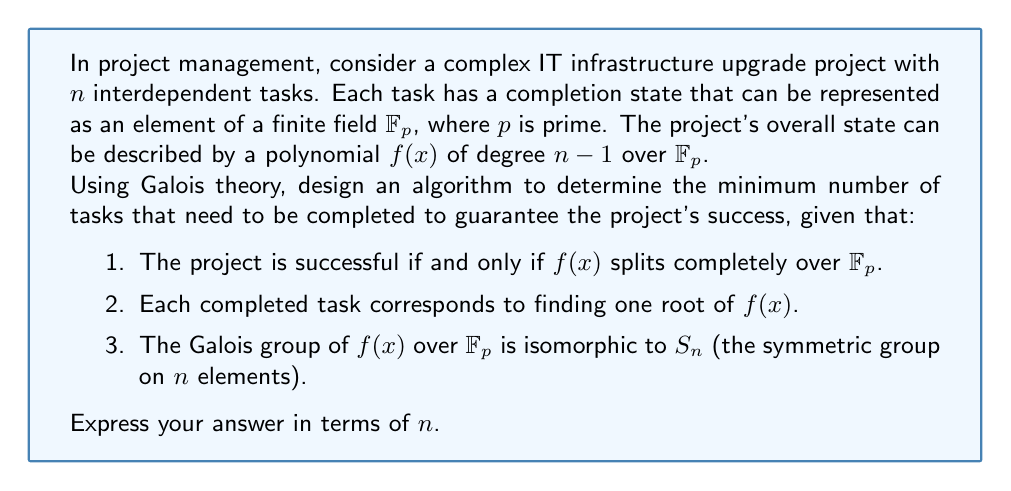Show me your answer to this math problem. Let's approach this step-by-step using Galois theory:

1) First, recall that for a polynomial $f(x)$ of degree $n$ over a field $F$, the Galois group $Gal(f/F)$ is a subgroup of $S_n$.

2) In this case, we're given that $Gal(f/\mathbb{F}_p) \cong S_n$, which means the polynomial is as complicated as possible over $\mathbb{F}_p$.

3) The Fundamental Theorem of Galois Theory states that there's a one-to-one correspondence between subfields of the splitting field of $f(x)$ and subgroups of $Gal(f/\mathbb{F}_p)$.

4) Each time we complete a task (find a root), we're essentially adjoining that root to $\mathbb{F}_p$. This corresponds to moving to a subfield of the splitting field.

5) The question is asking for the minimum number of roots we need to find to guarantee that all roots are in the field (i.e., the polynomial splits completely).

6) In Galois theory terms, we're looking for the smallest subgroup of $S_n$ that guarantees the corresponding fixed field is the entire splitting field.

7) The key insight is that $S_n$ is generated by transpositions. In fact, it's generated by the $n-1$ transpositions $(1 2), (2 3), ..., (n-1 n)$.

8) This means that if we fix $n-1$ roots, the last root must also be in our field, as the Galois group of the remaining polynomial would be trivial.

9) Therefore, we need to complete at least $n-1$ tasks to guarantee the project's success.

This approach leverages Galois theory to develop a sophisticated algorithm for project management, aligning with the IT director's need for insights on navigating project pitfalls.
Answer: $n-1$ tasks 